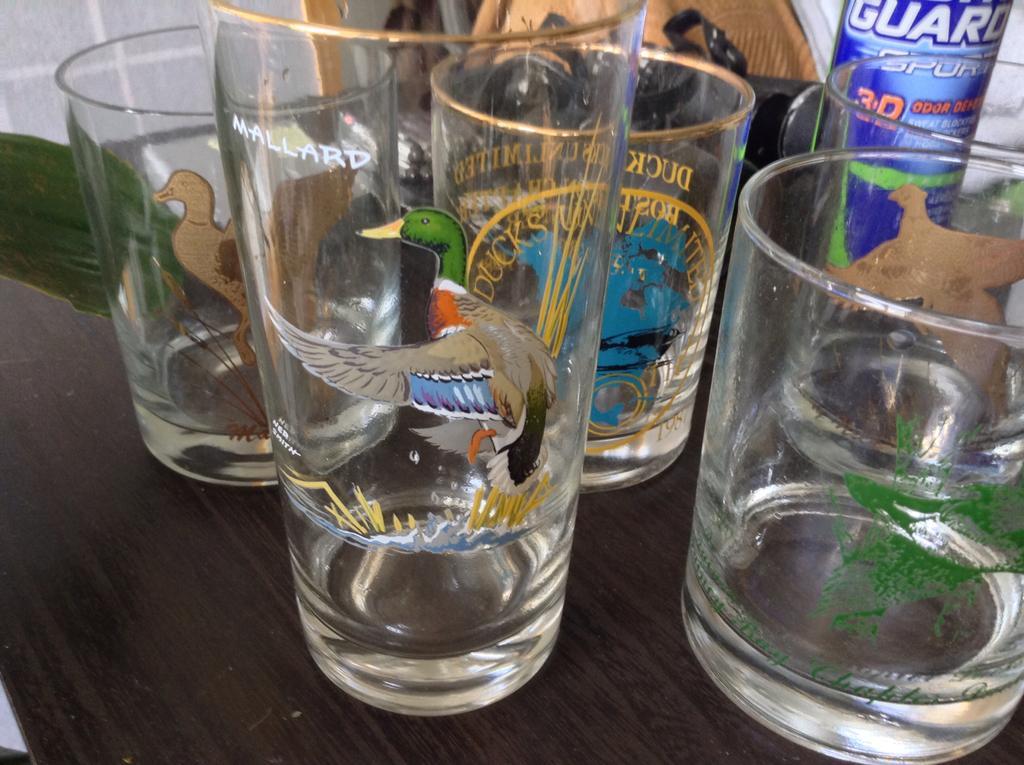Please provide a concise description of this image. We can see glasses and objects on the table and on these glasses we can see painting. Background we can see wall and we can see green leaf. 